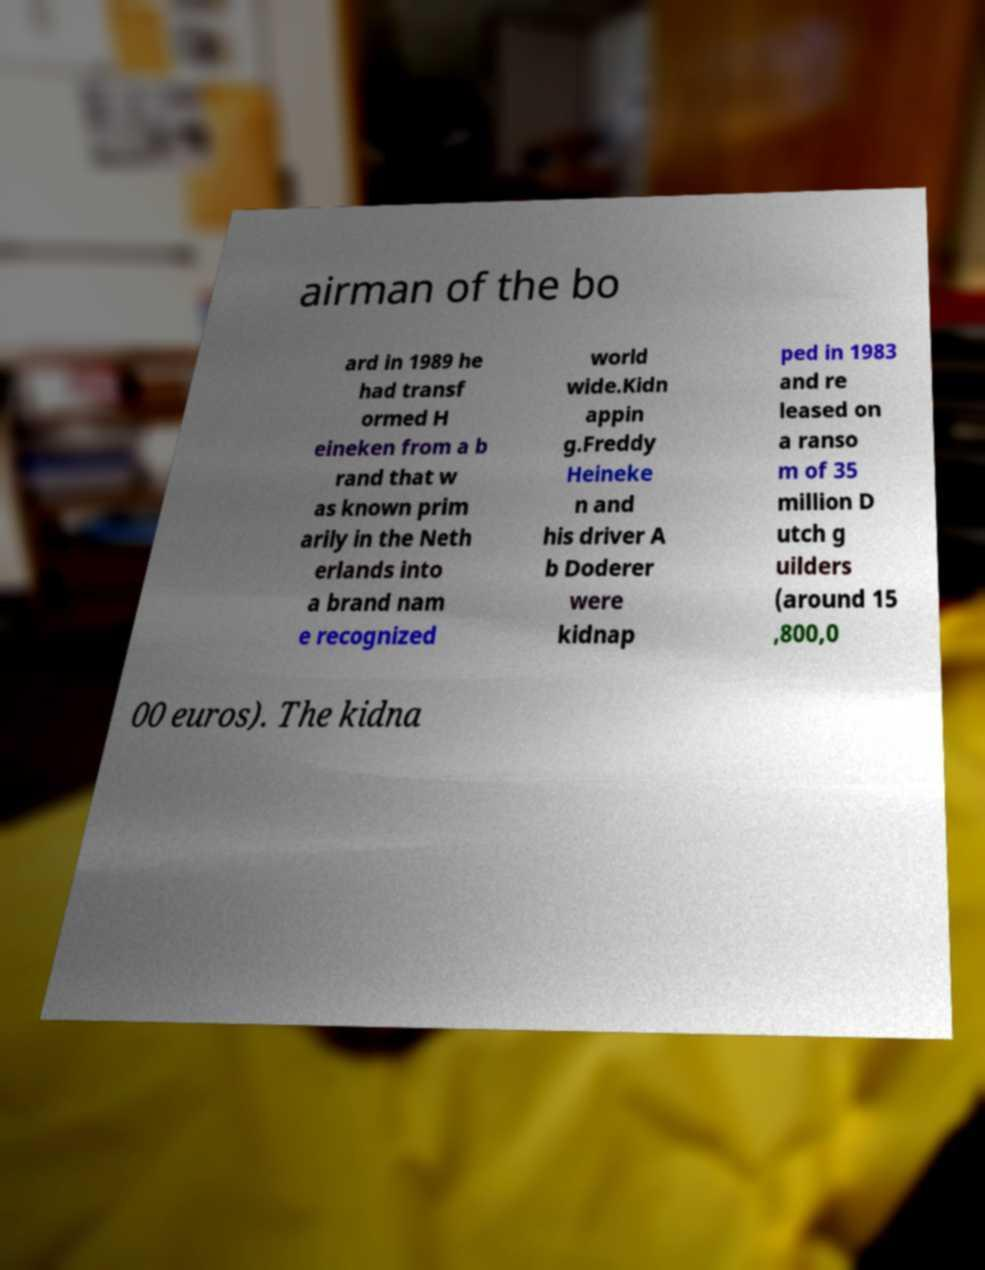What messages or text are displayed in this image? I need them in a readable, typed format. airman of the bo ard in 1989 he had transf ormed H eineken from a b rand that w as known prim arily in the Neth erlands into a brand nam e recognized world wide.Kidn appin g.Freddy Heineke n and his driver A b Doderer were kidnap ped in 1983 and re leased on a ranso m of 35 million D utch g uilders (around 15 ,800,0 00 euros). The kidna 